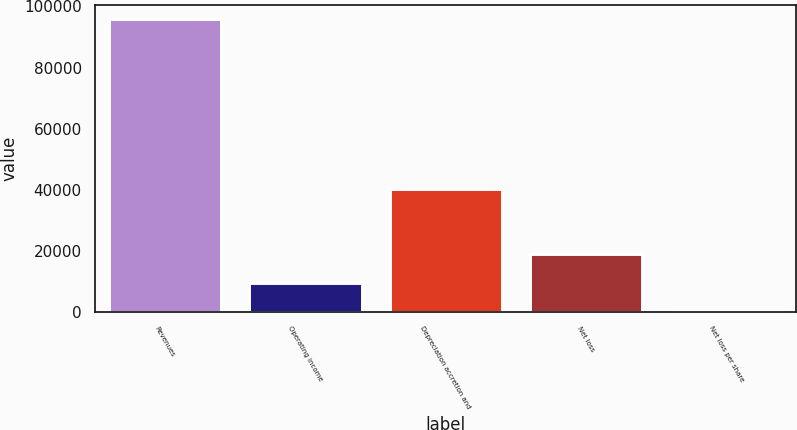Convert chart to OTSL. <chart><loc_0><loc_0><loc_500><loc_500><bar_chart><fcel>Revenues<fcel>Operating income<fcel>Depreciation accretion and<fcel>Net loss<fcel>Net loss per share<nl><fcel>95808<fcel>9580.94<fcel>40293<fcel>19161.7<fcel>0.16<nl></chart> 